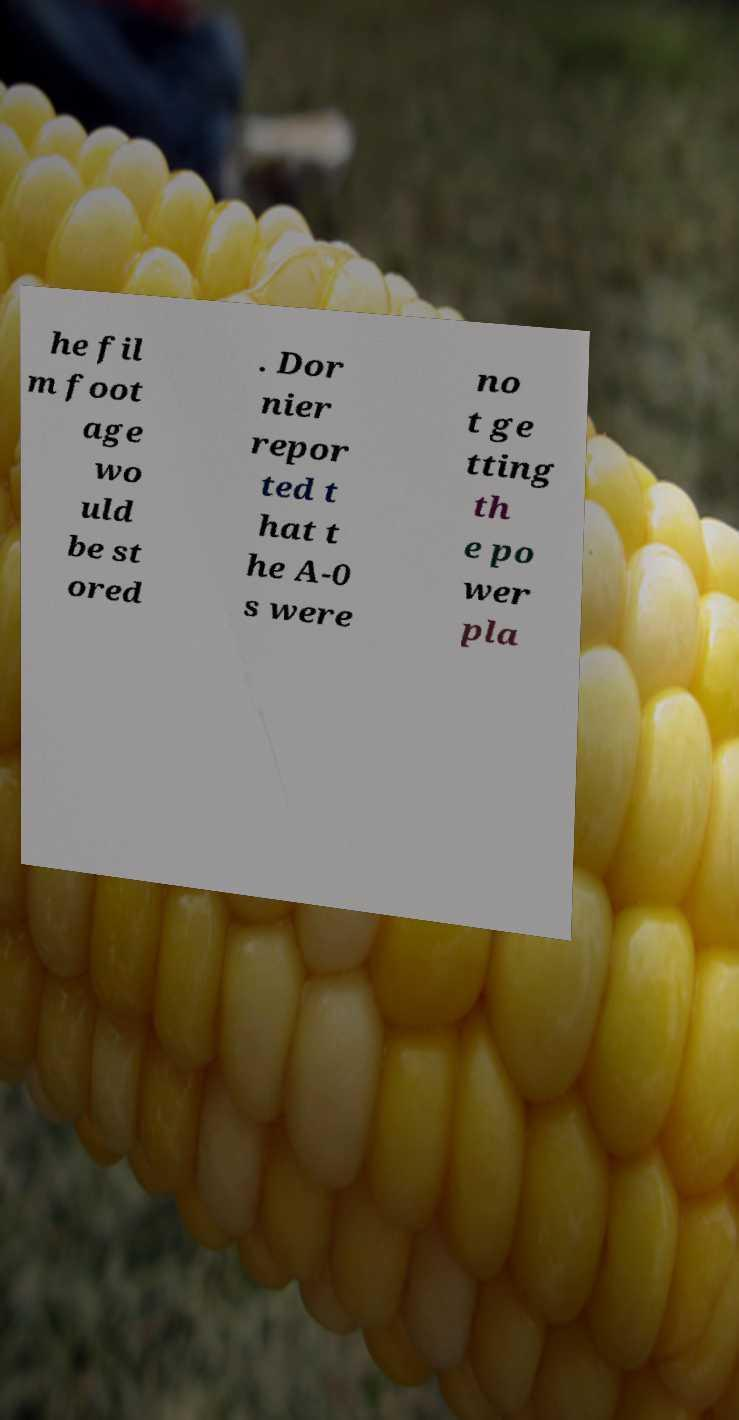Could you assist in decoding the text presented in this image and type it out clearly? he fil m foot age wo uld be st ored . Dor nier repor ted t hat t he A-0 s were no t ge tting th e po wer pla 